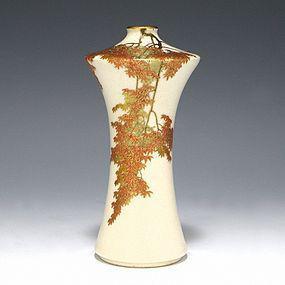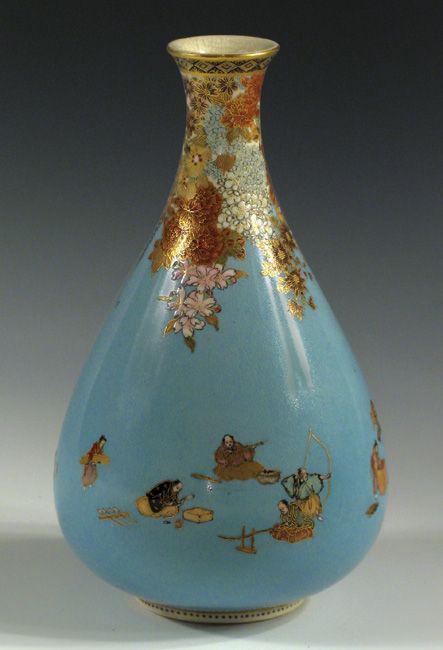The first image is the image on the left, the second image is the image on the right. Analyze the images presented: Is the assertion "There is a vase with a lot of blue on it with a wide bottom and a skinny neck at the top." valid? Answer yes or no. Yes. 